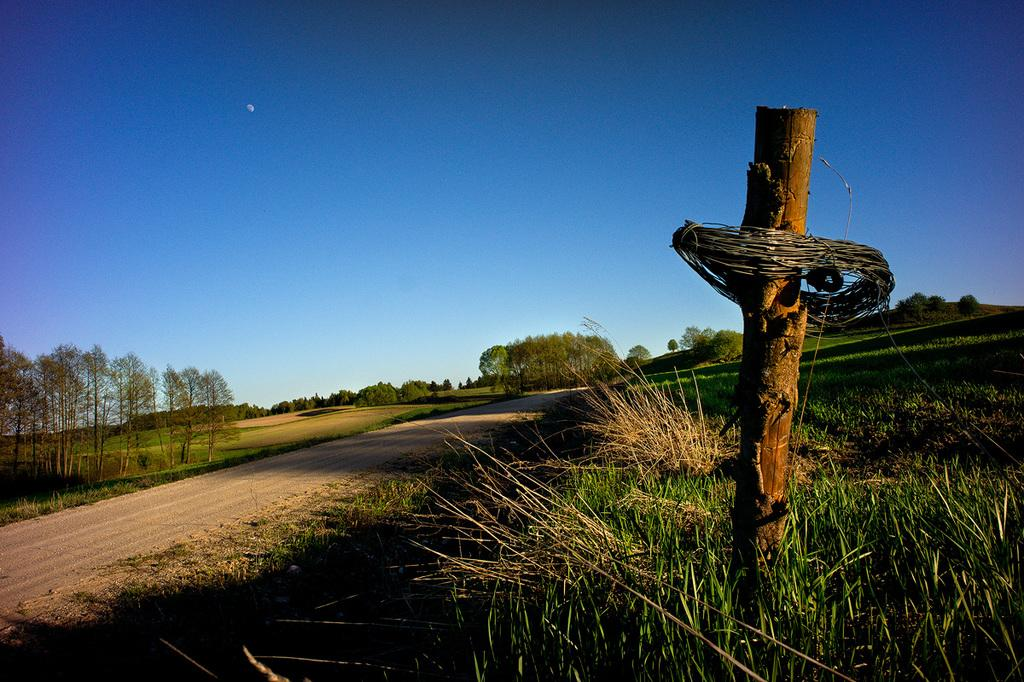What object can be seen in the image that is made of wood? There is a wooden stick in the image. What type of natural elements are visible in the background of the image? We start by identifying the wooden object mentioned in the facts, which is the wooden stick. Then, we focus on the background of the image, noting that there are plants and trees present. We describe their color as green to provide more detail about their appearance. Finally, we mention the color of the sky, which is blue, to give an idea of the overall setting and atmosphere of the image. Absurd Question/Answer: Who is the queen of the plants and trees in the image? There is no queen mentioned or depicted in the image; it only shows plants, trees, and a wooden stick. Can you tell me who the owner of the wooden stick is? There is no information about the ownership of the wooden stick in the image. What part of the brain can be seen in the image? There is no brain present in the image; it only shows a wooden stick, plants, trees, and the sky. 